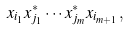<formula> <loc_0><loc_0><loc_500><loc_500>x _ { i _ { 1 } } x _ { j _ { 1 } } ^ { * } \cdots x _ { j _ { m } } ^ { * } x _ { i _ { m + 1 } } ,</formula> 